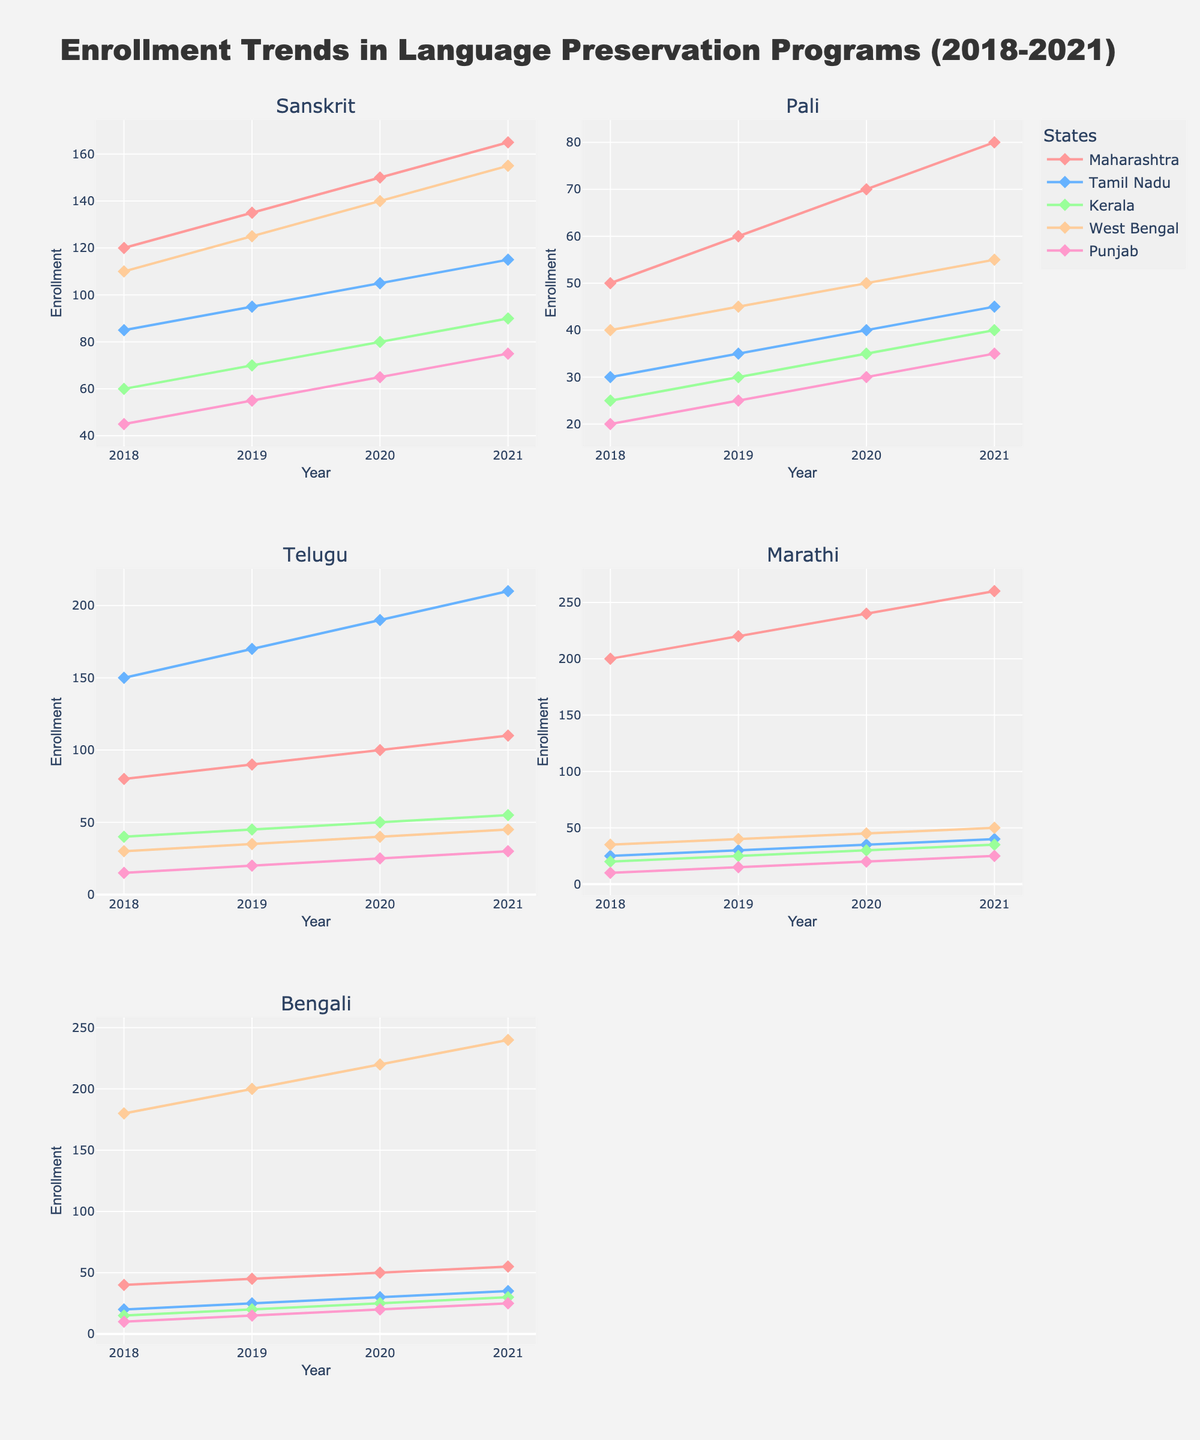What's the highest price recorded for Extra Long Staple cotton between 2018 and 2023? The plot shows the yearly price trend for Extra Long Staple cotton. By looking at the points on the "Extra Long Staple" subplot, the highest price can be observed.
Answer: 4.10 What is the trend in the prices of Medium Staple cotton from 2018 to 2023? To find the trend, observe the "Medium Staple" subplot and note the general direction of the price points over the years.
Answer: Increasing How much did the price of Short Staple cotton change from 2022 to 2023? Refer to the "Short Staple" subplot and subtract the 2022 price from the 2023 price: 2.25 - 2.35 = -0.10.
Answer: -0.10 In which year did Long Staple cotton see the highest price increase compared to the previous year? Examine the "Long Staple" subplot and calculate the annual differences. The greatest increase is between 2020 and 2021: 3.20 - 2.70 = 0.50.
Answer: 2021 What's the average price of Long Staple cotton over the 6 years? Sum the prices of Long Staple cotton from 2018 to 2023 and divide by 6: (2.80 + 2.95 + 2.70 + 3.20 + 3.45 + 3.30) / 6 = 18.40 / 6.
Answer: 3.07 What's the gap in 2023 prices between Extra Long Staple and Short Staple cotton? Find the 2023 prices for both types from their subplots and subtract the Short Staple price from the Extra Long Staple price: 3.95 - 2.25.
Answer: 1.70 Which quality grade has the most stable prices between 2018 and 2023? For stability, look at the volatility in the subplots. "Short Staple" prices show the least fluctuation.
Answer: Short Staple How did the price of Extra Long Staple cotton in 2021 compare to its price in 2020? Locate the prices for Extra Long Staple cotton in 2020 and 2021 in the subplot and compare: 3.80 (2021) to 3.15 (2020).
Answer: Increased Did any quality grade have a consistent year-over-year price increase from 2018 to 2023? Check each subplot and observe if there is a consistent upward trend. None of the quality grades consistently increased every year, but Extra Long Staple had an overall upward trend.
Answer: No 